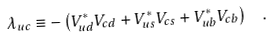<formula> <loc_0><loc_0><loc_500><loc_500>\lambda _ { u c } \equiv - \left ( V _ { u d } ^ { * } V _ { c d } + V _ { u s } ^ { * } V _ { c s } + V _ { u b } ^ { * } V _ { c b } \right ) \ \ .</formula> 